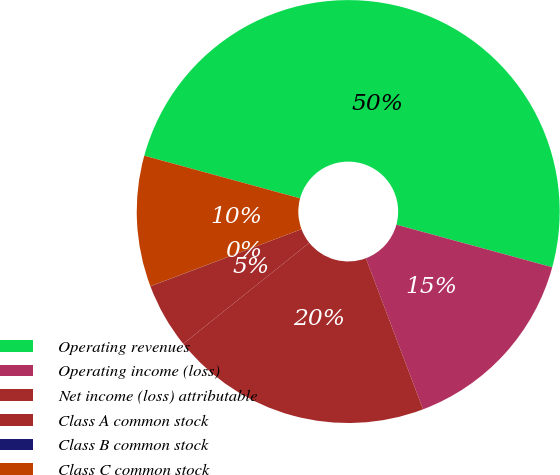Convert chart to OTSL. <chart><loc_0><loc_0><loc_500><loc_500><pie_chart><fcel>Operating revenues<fcel>Operating income (loss)<fcel>Net income (loss) attributable<fcel>Class A common stock<fcel>Class B common stock<fcel>Class C common stock<nl><fcel>49.99%<fcel>15.0%<fcel>20.0%<fcel>5.0%<fcel>0.01%<fcel>10.0%<nl></chart> 